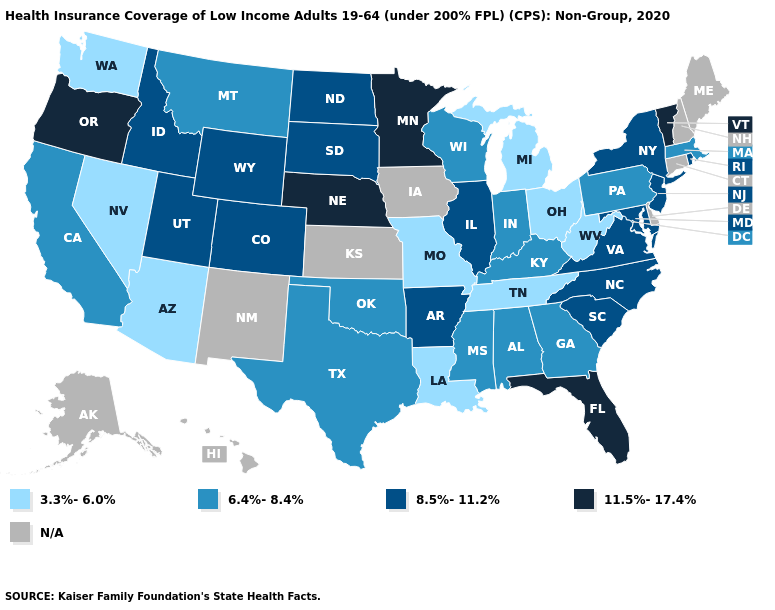What is the value of North Carolina?
Answer briefly. 8.5%-11.2%. Among the states that border Wisconsin , does Minnesota have the lowest value?
Quick response, please. No. Does Kentucky have the lowest value in the South?
Give a very brief answer. No. Name the states that have a value in the range 11.5%-17.4%?
Short answer required. Florida, Minnesota, Nebraska, Oregon, Vermont. Among the states that border Utah , does Colorado have the lowest value?
Be succinct. No. Name the states that have a value in the range 8.5%-11.2%?
Give a very brief answer. Arkansas, Colorado, Idaho, Illinois, Maryland, New Jersey, New York, North Carolina, North Dakota, Rhode Island, South Carolina, South Dakota, Utah, Virginia, Wyoming. What is the value of Oregon?
Give a very brief answer. 11.5%-17.4%. Name the states that have a value in the range N/A?
Quick response, please. Alaska, Connecticut, Delaware, Hawaii, Iowa, Kansas, Maine, New Hampshire, New Mexico. Name the states that have a value in the range 6.4%-8.4%?
Concise answer only. Alabama, California, Georgia, Indiana, Kentucky, Massachusetts, Mississippi, Montana, Oklahoma, Pennsylvania, Texas, Wisconsin. What is the value of Utah?
Concise answer only. 8.5%-11.2%. What is the highest value in the USA?
Give a very brief answer. 11.5%-17.4%. Does Vermont have the highest value in the USA?
Give a very brief answer. Yes. Name the states that have a value in the range N/A?
Short answer required. Alaska, Connecticut, Delaware, Hawaii, Iowa, Kansas, Maine, New Hampshire, New Mexico. Does Arizona have the lowest value in the West?
Give a very brief answer. Yes. 